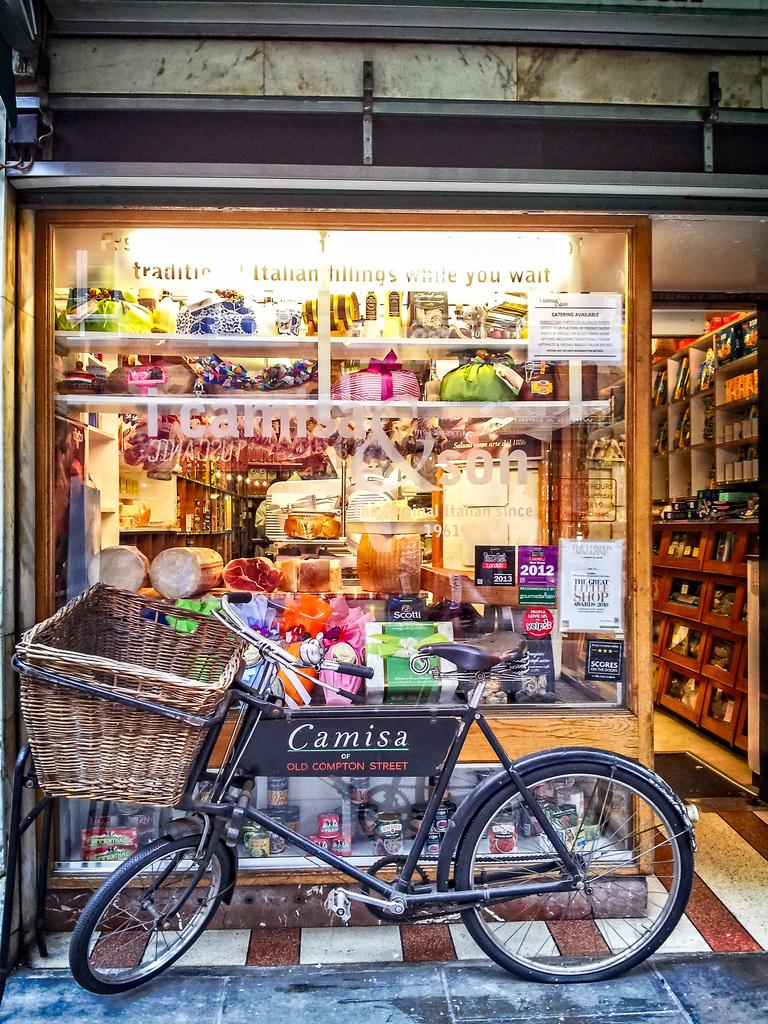Provide a one-sentence caption for the provided image. A bicycle with the name plate saying Camisa is in front of a stroe with colorful displays. 